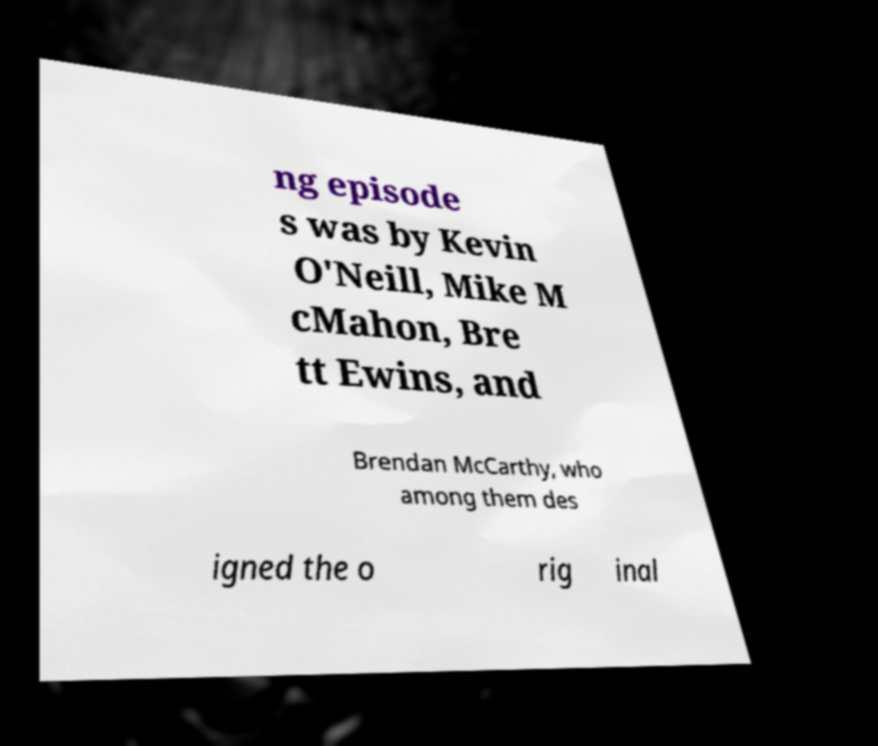For documentation purposes, I need the text within this image transcribed. Could you provide that? ng episode s was by Kevin O'Neill, Mike M cMahon, Bre tt Ewins, and Brendan McCarthy, who among them des igned the o rig inal 